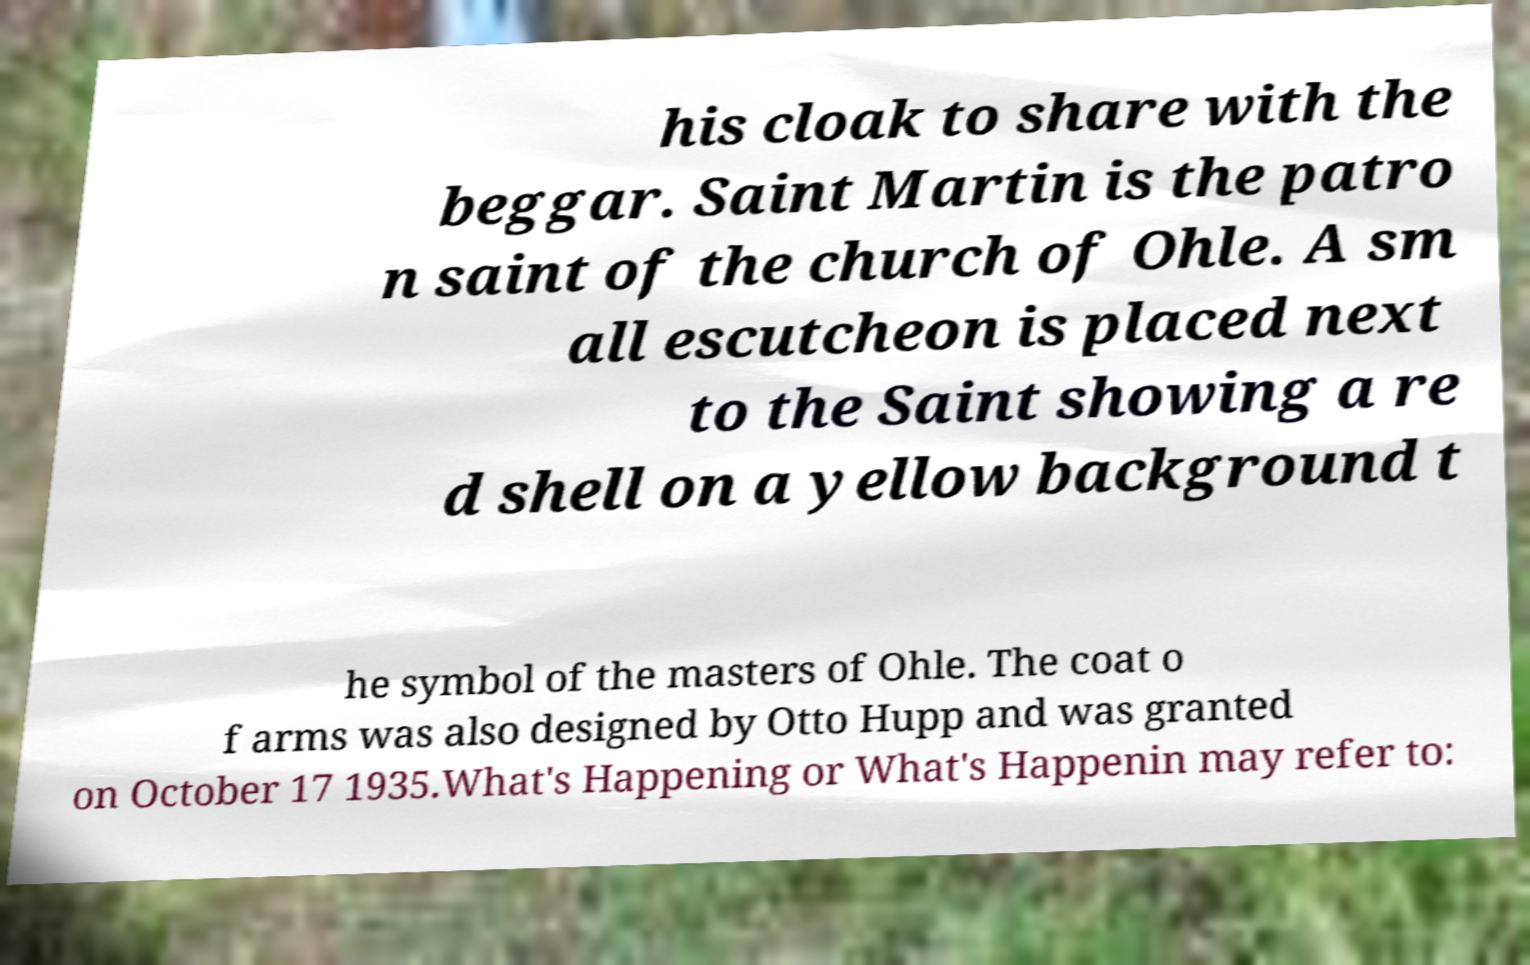Can you accurately transcribe the text from the provided image for me? his cloak to share with the beggar. Saint Martin is the patro n saint of the church of Ohle. A sm all escutcheon is placed next to the Saint showing a re d shell on a yellow background t he symbol of the masters of Ohle. The coat o f arms was also designed by Otto Hupp and was granted on October 17 1935.What's Happening or What's Happenin may refer to: 